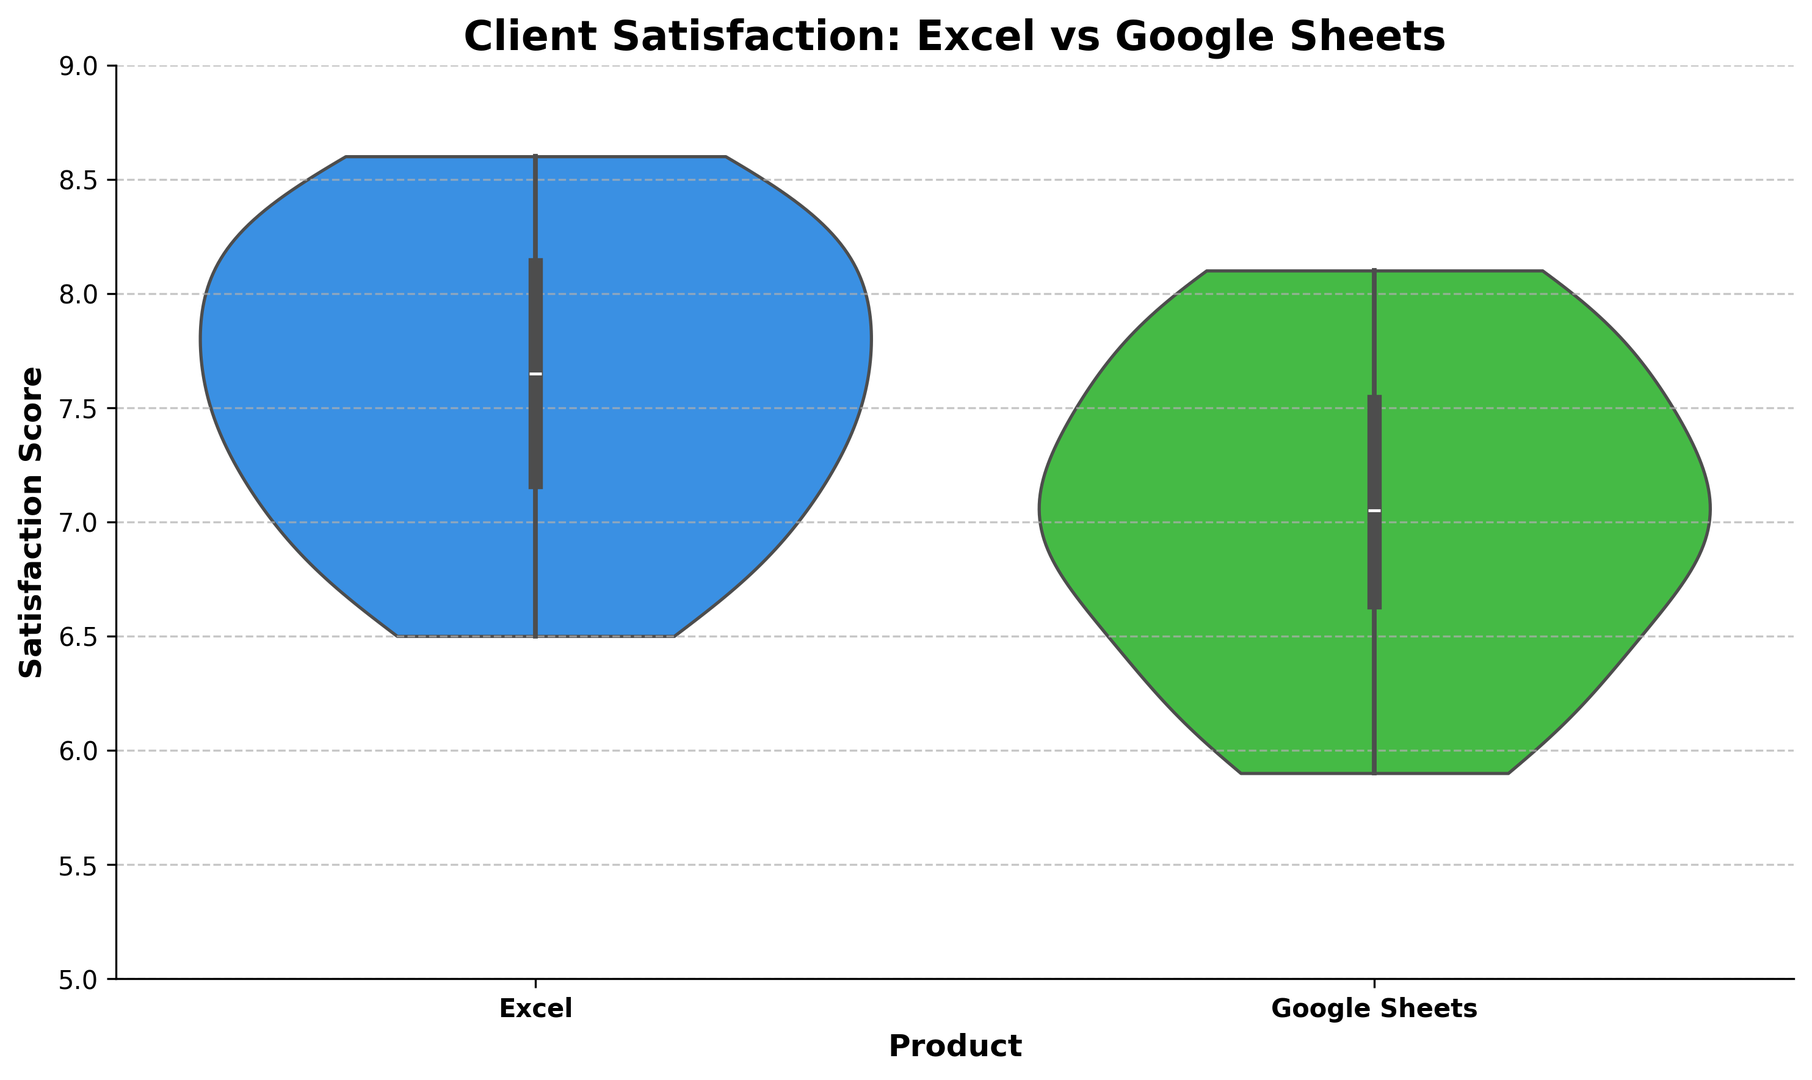Which product has a higher median satisfaction score? The violin plots include box plots that display the medians. By comparing the medians for each product, we see that Excel's median line is slightly higher than Google Sheets' median line.
Answer: Excel What's the interquartile range (IQR) of satisfaction scores for Google Sheets? The IQR is the range between the first quartile (Q1) and the third quartile (Q3). Visually, these are the bounds of the central box within the violin plot. For Google Sheets, Q1 is near 6.5 and Q3 is around 7.5. Therefore, the IQR is approximately 7.5 - 6.5 = 1.
Answer: 1 Which product shows a wider distribution of satisfaction scores? The width of the violin plots at various points indicates the distribution width. Google Sheets has a wider plot at certain regions of the satisfaction scores compared to Excel, indicating a wider distribution.
Answer: Google Sheets Are there any outliers in either product’s satisfaction scores? The violin plot includes any outliers as individual points beyond the whiskers. In this plot, there do not appear to be any visible outliers in either product’s satisfaction scores.
Answer: No What's the range of satisfaction scores for Excel consultations? The range is the difference between the maximum and minimum values. For Excel, the plot indicates a minimum of around 6.5 and a maximum of around 8.6, so the range is approximately 8.6 - 6.5 = 2.1.
Answer: 2.1 Which product has the highest satisfaction score observed? By observing the uppermost value in the violin plots, we see that Excel reaches just slightly beyond 8.5, while Google Sheets does not reach as high.
Answer: Excel What is the approximate average height (i.e., satisfaction score) of the highest density region for Google Sheets? The highest density region of a violin plot is where the plot is the widest. For Google Sheets, this is around the satisfaction score of 7.0 - 7.5.
Answer: 7.0 - 7.5 Comparing the lower quartiles of both products, which one is higher? The lower quartile (Q1) is the bottom of the box in the violin plot. Comparing these, we see that Excel’s Q1 is slightly higher than Google Sheets' Q1.
Answer: Excel What is the difference between the upper quartiles of Excel and Google Sheets? The upper quartile (Q3) is the top of the box in the violin plot. Excel's Q3 is near 8.2, and Google Sheets' Q3 is around 7.5. Thus, the difference is approximately 8.2 - 7.5 = 0.7.
Answer: 0.7 What's the overall range of satisfaction scores for Google Sheets? The overall range is the difference between the maximum and minimum values in the plot. For Google Sheets, these values are approximately 5.9 and 8.1, thus the range is 8.1 - 5.9 = 2.2.
Answer: 2.2 